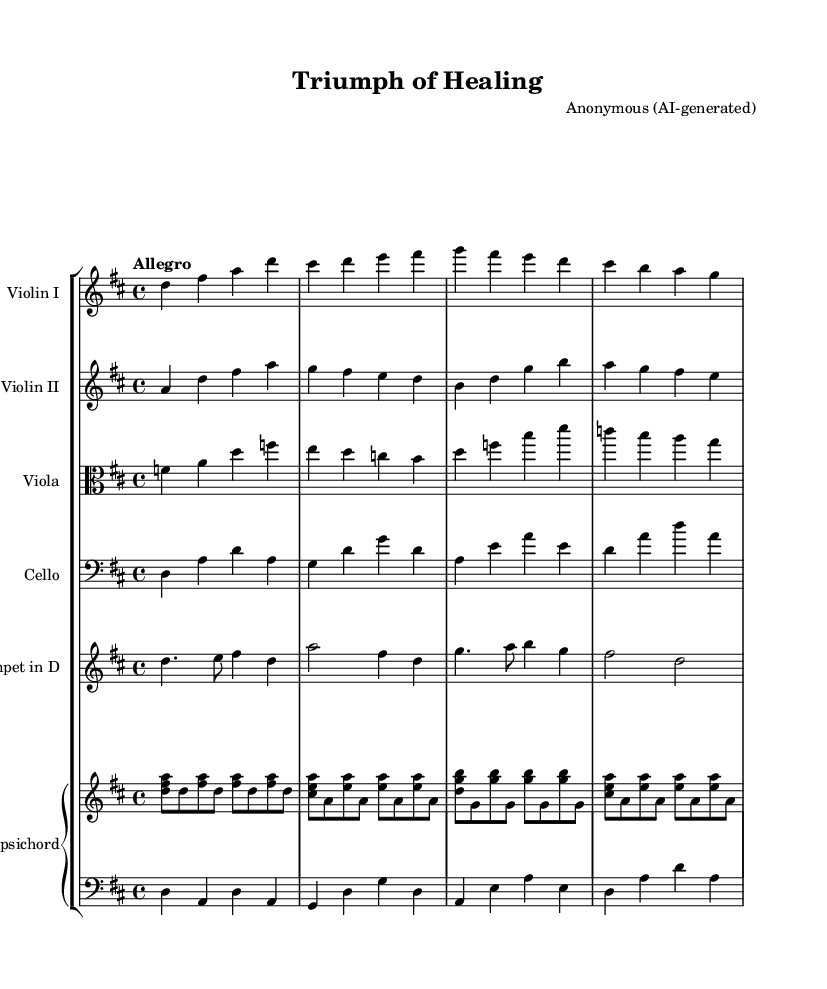What is the key signature of this music? The key signature is indicated at the beginning of the staff, showing two sharps, which corresponds to D major.
Answer: D major What is the time signature of this music? The time signature is shown as a fraction at the beginning of the staff; it is four beats per measure, indicated by 4/4.
Answer: 4/4 What is the tempo marking found in this sheet music? The tempo marking is written above the staff as "Allegro," which indicates a fast pace.
Answer: Allegro How many different instruments are used in this score? By counting each staff in the score, there are six distinct instruments represented: two violins, one viola, one cello, one trumpet, and one harpsichord part.
Answer: Six Which note is the starting note for Violin I? The starting note can be seen in the first measure of the Violin I staff; it is a D note on the second line of the treble clef.
Answer: D Is there a trumpet part in this orchestration? The presence of a dedicated staff labeled "Trumpet in D" confirms that there is indeed a trumpet part included in the orchestration.
Answer: Yes What is a characteristic feature of Baroque orchestration represented in this piece? The use of a harpsichord in the continuo role accompanies the other instruments, which is a hallmark of Baroque music.
Answer: Harpsichord 